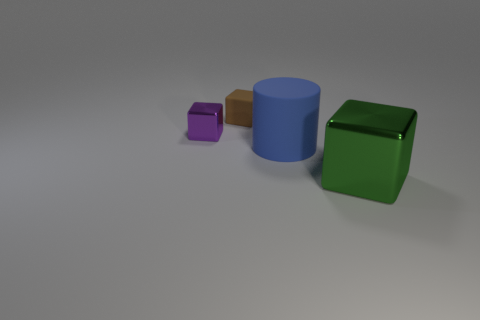Subtract all green blocks. How many blocks are left? 2 Add 4 brown matte blocks. How many objects exist? 8 Subtract all cubes. How many objects are left? 1 Subtract all brown cubes. Subtract all green cylinders. How many cubes are left? 2 Subtract all red cubes. How many yellow cylinders are left? 0 Subtract all large green shiny cubes. Subtract all small green cubes. How many objects are left? 3 Add 1 purple metal things. How many purple metal things are left? 2 Add 1 small brown matte blocks. How many small brown matte blocks exist? 2 Subtract 0 gray cylinders. How many objects are left? 4 